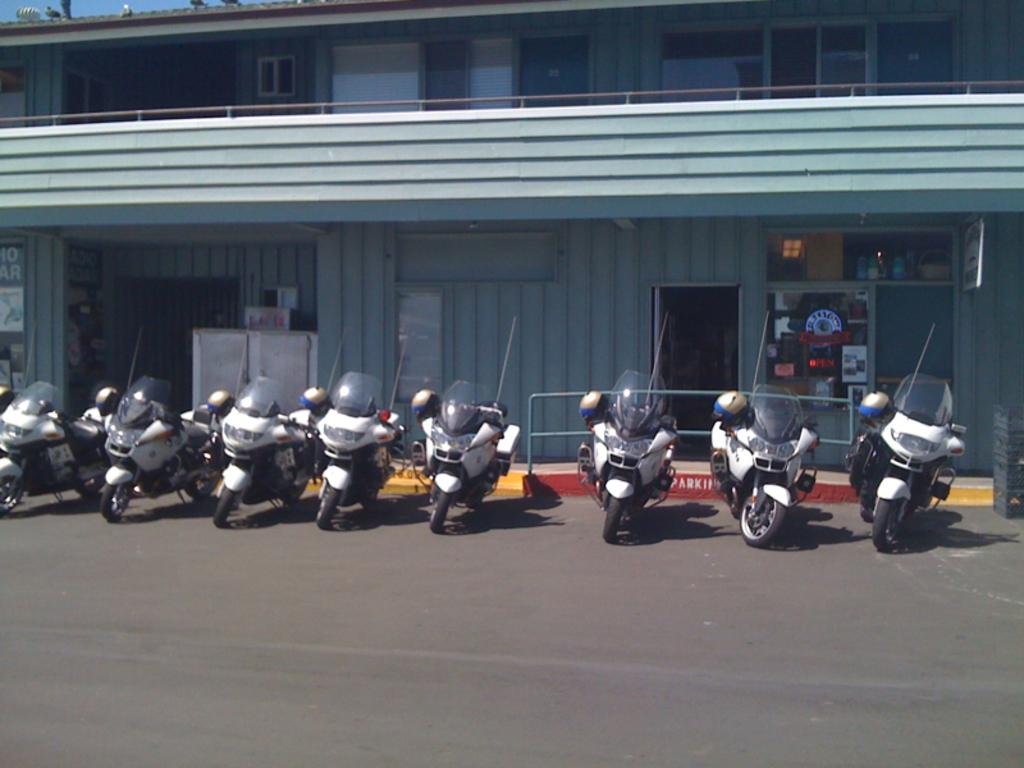What is the main subject of the image? The main subject of the image is many bikes on the road. What can be seen in the background of the image? In the background of the image, there is a building, doors, windows, birds, and the sky. What type of trade is happening between the birds in the image? There is no trade happening between the birds in the image, as they are not engaging in any activity that suggests a trade. 